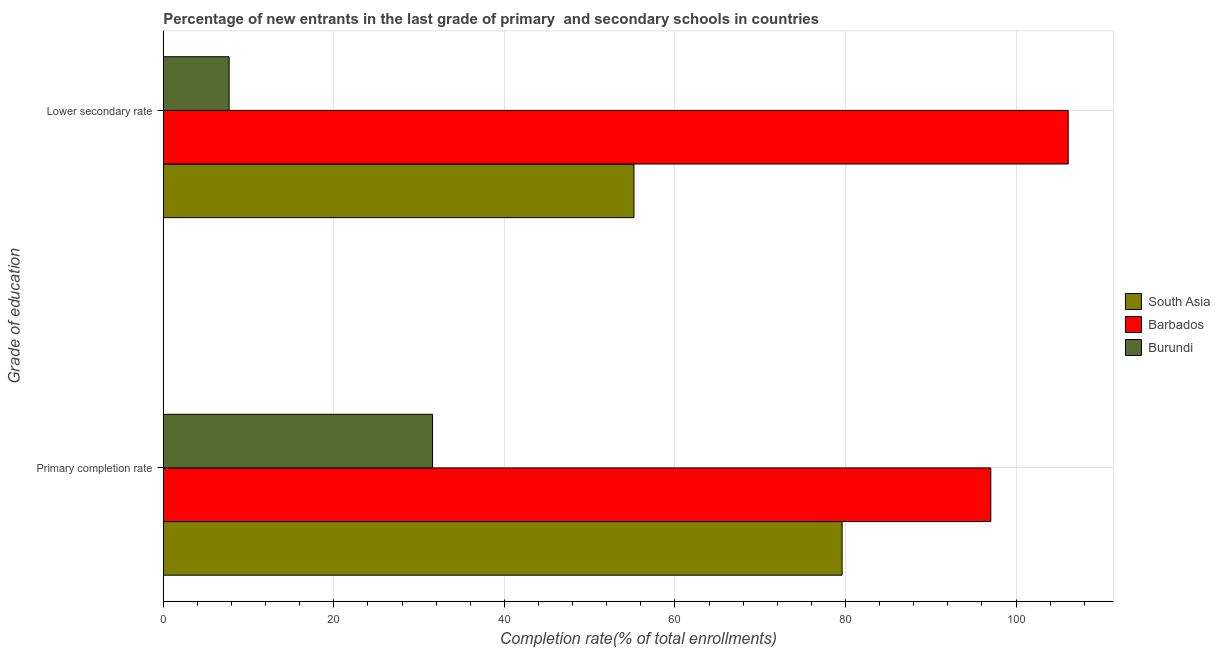How many different coloured bars are there?
Give a very brief answer. 3. How many bars are there on the 2nd tick from the bottom?
Provide a succinct answer. 3. What is the label of the 1st group of bars from the top?
Offer a very short reply. Lower secondary rate. What is the completion rate in secondary schools in South Asia?
Ensure brevity in your answer.  55.19. Across all countries, what is the maximum completion rate in secondary schools?
Your response must be concise. 106.11. Across all countries, what is the minimum completion rate in secondary schools?
Keep it short and to the point. 7.72. In which country was the completion rate in primary schools maximum?
Keep it short and to the point. Barbados. In which country was the completion rate in primary schools minimum?
Provide a short and direct response. Burundi. What is the total completion rate in secondary schools in the graph?
Your answer should be very brief. 169.02. What is the difference between the completion rate in primary schools in Barbados and that in Burundi?
Give a very brief answer. 65.46. What is the difference between the completion rate in primary schools in Burundi and the completion rate in secondary schools in Barbados?
Your answer should be very brief. -74.53. What is the average completion rate in primary schools per country?
Give a very brief answer. 69.4. What is the difference between the completion rate in secondary schools and completion rate in primary schools in Burundi?
Your answer should be very brief. -23.85. In how many countries, is the completion rate in primary schools greater than 84 %?
Offer a terse response. 1. What is the ratio of the completion rate in primary schools in Barbados to that in Burundi?
Your answer should be compact. 3.07. What does the 1st bar from the top in Lower secondary rate represents?
Your answer should be very brief. Burundi. What does the 2nd bar from the bottom in Lower secondary rate represents?
Keep it short and to the point. Barbados. How many bars are there?
Provide a short and direct response. 6. What is the difference between two consecutive major ticks on the X-axis?
Provide a succinct answer. 20. Does the graph contain any zero values?
Offer a terse response. No. Does the graph contain grids?
Your answer should be compact. Yes. How many legend labels are there?
Provide a short and direct response. 3. What is the title of the graph?
Provide a short and direct response. Percentage of new entrants in the last grade of primary  and secondary schools in countries. Does "Mauritius" appear as one of the legend labels in the graph?
Your response must be concise. No. What is the label or title of the X-axis?
Offer a very short reply. Completion rate(% of total enrollments). What is the label or title of the Y-axis?
Your answer should be very brief. Grade of education. What is the Completion rate(% of total enrollments) in South Asia in Primary completion rate?
Keep it short and to the point. 79.6. What is the Completion rate(% of total enrollments) of Barbados in Primary completion rate?
Provide a short and direct response. 97.03. What is the Completion rate(% of total enrollments) of Burundi in Primary completion rate?
Offer a very short reply. 31.57. What is the Completion rate(% of total enrollments) of South Asia in Lower secondary rate?
Ensure brevity in your answer.  55.19. What is the Completion rate(% of total enrollments) of Barbados in Lower secondary rate?
Ensure brevity in your answer.  106.11. What is the Completion rate(% of total enrollments) in Burundi in Lower secondary rate?
Provide a succinct answer. 7.72. Across all Grade of education, what is the maximum Completion rate(% of total enrollments) of South Asia?
Offer a very short reply. 79.6. Across all Grade of education, what is the maximum Completion rate(% of total enrollments) of Barbados?
Your response must be concise. 106.11. Across all Grade of education, what is the maximum Completion rate(% of total enrollments) in Burundi?
Offer a very short reply. 31.57. Across all Grade of education, what is the minimum Completion rate(% of total enrollments) of South Asia?
Your answer should be very brief. 55.19. Across all Grade of education, what is the minimum Completion rate(% of total enrollments) in Barbados?
Give a very brief answer. 97.03. Across all Grade of education, what is the minimum Completion rate(% of total enrollments) in Burundi?
Make the answer very short. 7.72. What is the total Completion rate(% of total enrollments) in South Asia in the graph?
Offer a terse response. 134.79. What is the total Completion rate(% of total enrollments) of Barbados in the graph?
Offer a terse response. 203.14. What is the total Completion rate(% of total enrollments) in Burundi in the graph?
Make the answer very short. 39.29. What is the difference between the Completion rate(% of total enrollments) of South Asia in Primary completion rate and that in Lower secondary rate?
Make the answer very short. 24.41. What is the difference between the Completion rate(% of total enrollments) of Barbados in Primary completion rate and that in Lower secondary rate?
Your answer should be compact. -9.07. What is the difference between the Completion rate(% of total enrollments) of Burundi in Primary completion rate and that in Lower secondary rate?
Provide a short and direct response. 23.85. What is the difference between the Completion rate(% of total enrollments) of South Asia in Primary completion rate and the Completion rate(% of total enrollments) of Barbados in Lower secondary rate?
Your answer should be very brief. -26.51. What is the difference between the Completion rate(% of total enrollments) of South Asia in Primary completion rate and the Completion rate(% of total enrollments) of Burundi in Lower secondary rate?
Keep it short and to the point. 71.88. What is the difference between the Completion rate(% of total enrollments) of Barbados in Primary completion rate and the Completion rate(% of total enrollments) of Burundi in Lower secondary rate?
Offer a terse response. 89.31. What is the average Completion rate(% of total enrollments) of South Asia per Grade of education?
Offer a terse response. 67.4. What is the average Completion rate(% of total enrollments) of Barbados per Grade of education?
Your response must be concise. 101.57. What is the average Completion rate(% of total enrollments) in Burundi per Grade of education?
Keep it short and to the point. 19.65. What is the difference between the Completion rate(% of total enrollments) of South Asia and Completion rate(% of total enrollments) of Barbados in Primary completion rate?
Ensure brevity in your answer.  -17.43. What is the difference between the Completion rate(% of total enrollments) of South Asia and Completion rate(% of total enrollments) of Burundi in Primary completion rate?
Offer a very short reply. 48.02. What is the difference between the Completion rate(% of total enrollments) in Barbados and Completion rate(% of total enrollments) in Burundi in Primary completion rate?
Ensure brevity in your answer.  65.46. What is the difference between the Completion rate(% of total enrollments) of South Asia and Completion rate(% of total enrollments) of Barbados in Lower secondary rate?
Keep it short and to the point. -50.91. What is the difference between the Completion rate(% of total enrollments) of South Asia and Completion rate(% of total enrollments) of Burundi in Lower secondary rate?
Your response must be concise. 47.47. What is the difference between the Completion rate(% of total enrollments) in Barbados and Completion rate(% of total enrollments) in Burundi in Lower secondary rate?
Provide a short and direct response. 98.39. What is the ratio of the Completion rate(% of total enrollments) in South Asia in Primary completion rate to that in Lower secondary rate?
Offer a terse response. 1.44. What is the ratio of the Completion rate(% of total enrollments) in Barbados in Primary completion rate to that in Lower secondary rate?
Offer a very short reply. 0.91. What is the ratio of the Completion rate(% of total enrollments) in Burundi in Primary completion rate to that in Lower secondary rate?
Your response must be concise. 4.09. What is the difference between the highest and the second highest Completion rate(% of total enrollments) of South Asia?
Keep it short and to the point. 24.41. What is the difference between the highest and the second highest Completion rate(% of total enrollments) in Barbados?
Give a very brief answer. 9.07. What is the difference between the highest and the second highest Completion rate(% of total enrollments) of Burundi?
Your response must be concise. 23.85. What is the difference between the highest and the lowest Completion rate(% of total enrollments) in South Asia?
Keep it short and to the point. 24.41. What is the difference between the highest and the lowest Completion rate(% of total enrollments) in Barbados?
Offer a very short reply. 9.07. What is the difference between the highest and the lowest Completion rate(% of total enrollments) in Burundi?
Your answer should be compact. 23.85. 